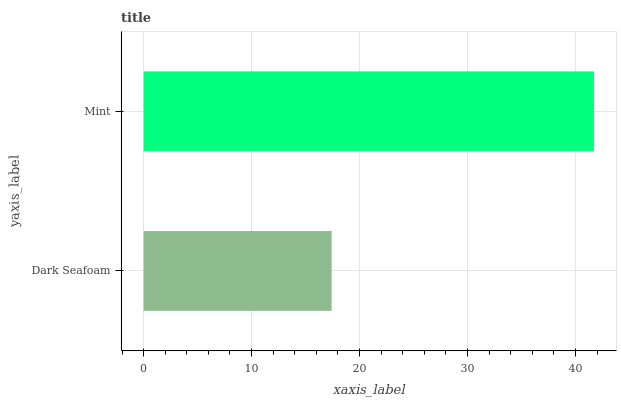Is Dark Seafoam the minimum?
Answer yes or no. Yes. Is Mint the maximum?
Answer yes or no. Yes. Is Mint the minimum?
Answer yes or no. No. Is Mint greater than Dark Seafoam?
Answer yes or no. Yes. Is Dark Seafoam less than Mint?
Answer yes or no. Yes. Is Dark Seafoam greater than Mint?
Answer yes or no. No. Is Mint less than Dark Seafoam?
Answer yes or no. No. Is Mint the high median?
Answer yes or no. Yes. Is Dark Seafoam the low median?
Answer yes or no. Yes. Is Dark Seafoam the high median?
Answer yes or no. No. Is Mint the low median?
Answer yes or no. No. 